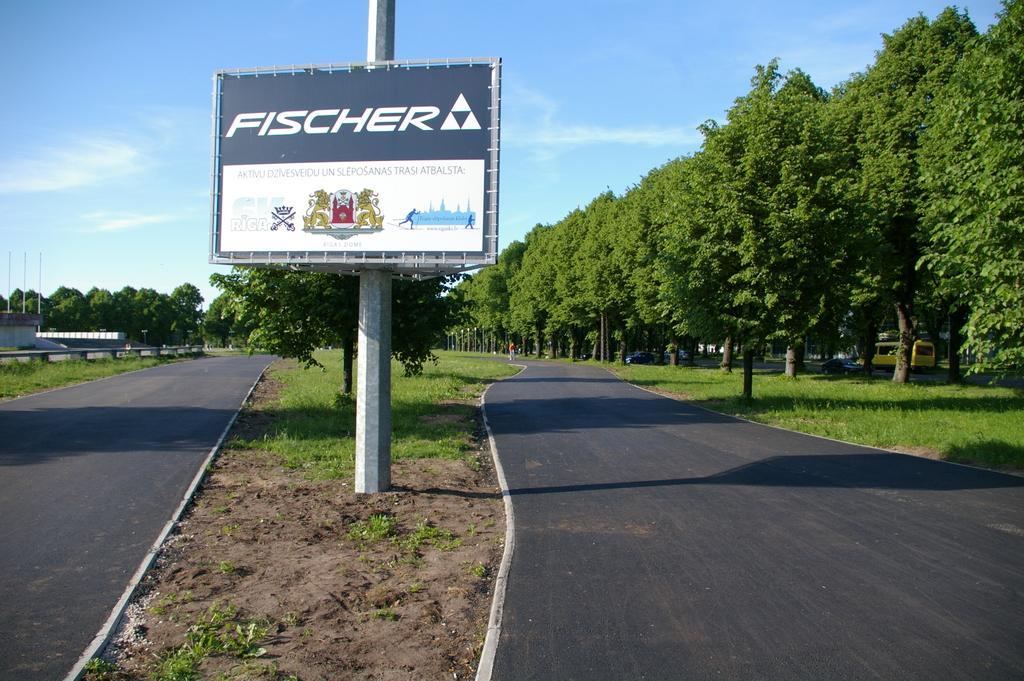Could you give a brief overview of what you see in this image? In this picture I can see the roads and in the middle of this picture I see a pole on which there is a hoarding and I see something is written on it and I see the logos and I see number of trees on both the sides and I see the grass. In the background I see the sky. 